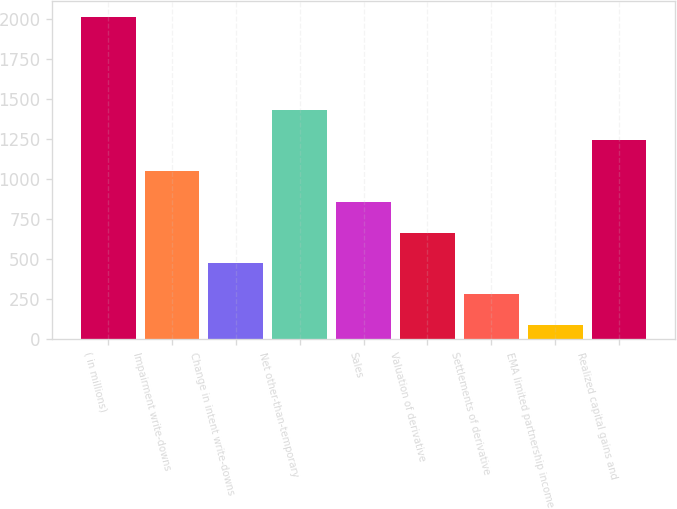Convert chart to OTSL. <chart><loc_0><loc_0><loc_500><loc_500><bar_chart><fcel>( in millions)<fcel>Impairment write-downs<fcel>Change in intent write-downs<fcel>Net other-than-temporary<fcel>Sales<fcel>Valuation of derivative<fcel>Settlements of derivative<fcel>EMA limited partnership income<fcel>Realized capital gains and<nl><fcel>2010<fcel>1049.5<fcel>473.2<fcel>1433.7<fcel>857.4<fcel>665.3<fcel>281.1<fcel>89<fcel>1241.6<nl></chart> 